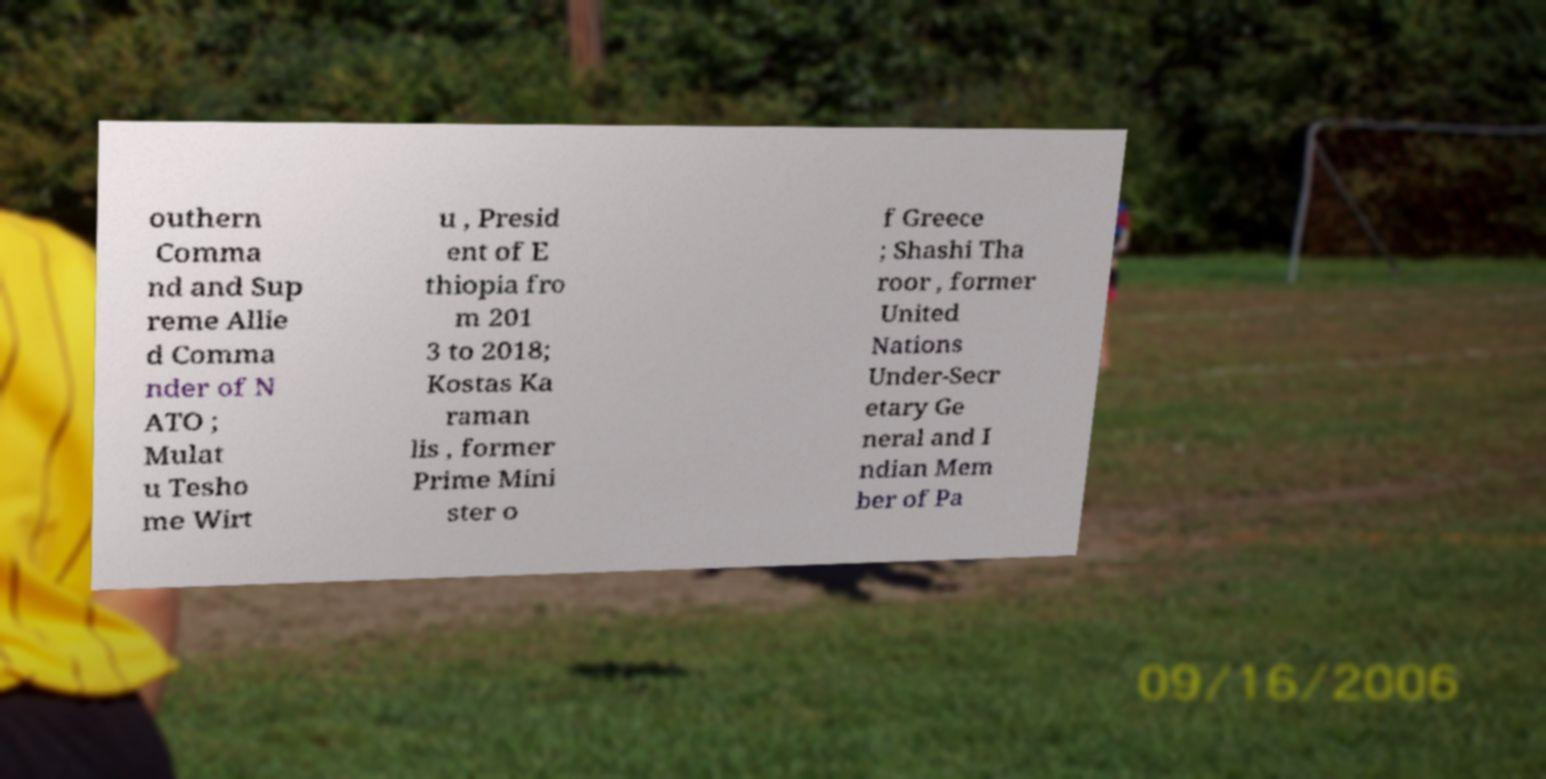Could you extract and type out the text from this image? outhern Comma nd and Sup reme Allie d Comma nder of N ATO ; Mulat u Tesho me Wirt u , Presid ent of E thiopia fro m 201 3 to 2018; Kostas Ka raman lis , former Prime Mini ster o f Greece ; Shashi Tha roor , former United Nations Under-Secr etary Ge neral and I ndian Mem ber of Pa 